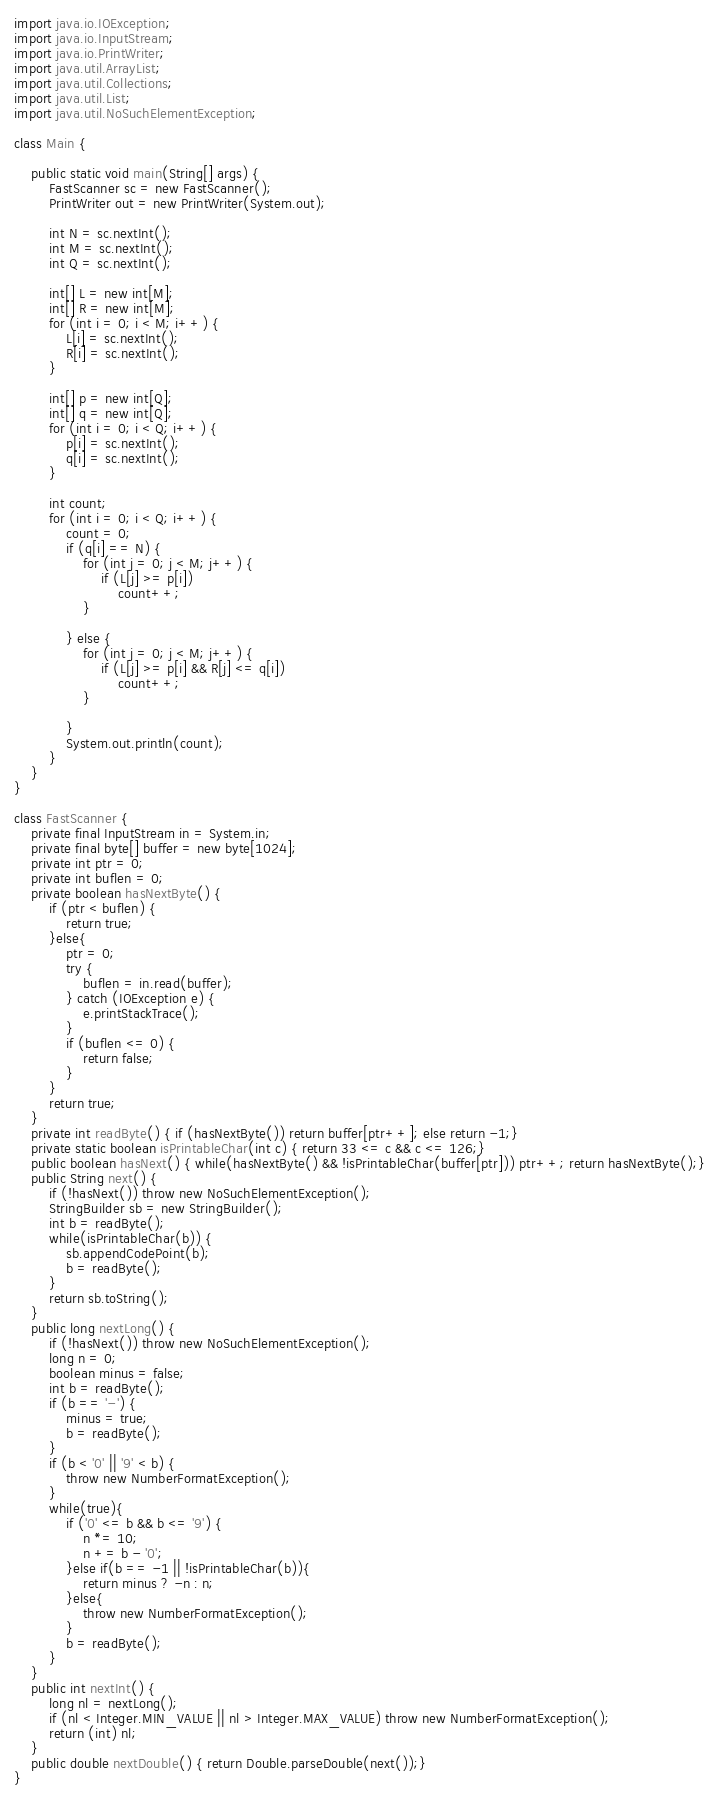Convert code to text. <code><loc_0><loc_0><loc_500><loc_500><_Java_>import java.io.IOException;
import java.io.InputStream;
import java.io.PrintWriter;
import java.util.ArrayList;
import java.util.Collections;
import java.util.List;
import java.util.NoSuchElementException;

class Main {
	
	public static void main(String[] args) {
		FastScanner sc = new FastScanner();
		PrintWriter out = new PrintWriter(System.out);
		
		int N = sc.nextInt();
		int M = sc.nextInt();
		int Q = sc.nextInt();
		
		int[] L = new int[M];
		int[] R = new int[M];
		for (int i = 0; i < M; i++) {
			L[i] = sc.nextInt();
			R[i] = sc.nextInt();
		}
		
		int[] p = new int[Q];
		int[] q = new int[Q];
		for (int i = 0; i < Q; i++) {
			p[i] = sc.nextInt();
			q[i] = sc.nextInt();
		}
		
		int count;
		for (int i = 0; i < Q; i++) {
			count = 0;
			if (q[i] == N) {
				for (int j = 0; j < M; j++) {
					if (L[j] >= p[i])
						count++;
				}
				
			} else {
				for (int j = 0; j < M; j++) {
					if (L[j] >= p[i] && R[j] <= q[i])
						count++;
				}
				
			}
			System.out.println(count);
		}
	}
}

class FastScanner {
    private final InputStream in = System.in;
    private final byte[] buffer = new byte[1024];
    private int ptr = 0;
    private int buflen = 0;
    private boolean hasNextByte() {
        if (ptr < buflen) {
            return true;
        }else{
            ptr = 0;
            try {
                buflen = in.read(buffer);
            } catch (IOException e) {
                e.printStackTrace();
            }
            if (buflen <= 0) {
                return false;
            }
        }
        return true;
    }
    private int readByte() { if (hasNextByte()) return buffer[ptr++]; else return -1;}
    private static boolean isPrintableChar(int c) { return 33 <= c && c <= 126;}
    public boolean hasNext() { while(hasNextByte() && !isPrintableChar(buffer[ptr])) ptr++; return hasNextByte();}
    public String next() {
        if (!hasNext()) throw new NoSuchElementException();
        StringBuilder sb = new StringBuilder();
        int b = readByte();
        while(isPrintableChar(b)) {
            sb.appendCodePoint(b);
            b = readByte();
        }
        return sb.toString();
    }
    public long nextLong() {
        if (!hasNext()) throw new NoSuchElementException();
        long n = 0;
        boolean minus = false;
        int b = readByte();
        if (b == '-') {
            minus = true;
            b = readByte();
        }
        if (b < '0' || '9' < b) {
            throw new NumberFormatException();
        }
        while(true){
            if ('0' <= b && b <= '9') {
                n *= 10;
                n += b - '0';
            }else if(b == -1 || !isPrintableChar(b)){
                return minus ? -n : n;
            }else{
                throw new NumberFormatException();
            }
            b = readByte();
        }
    }
    public int nextInt() {
        long nl = nextLong();
        if (nl < Integer.MIN_VALUE || nl > Integer.MAX_VALUE) throw new NumberFormatException();
        return (int) nl;
    }
    public double nextDouble() { return Double.parseDouble(next());}
}</code> 